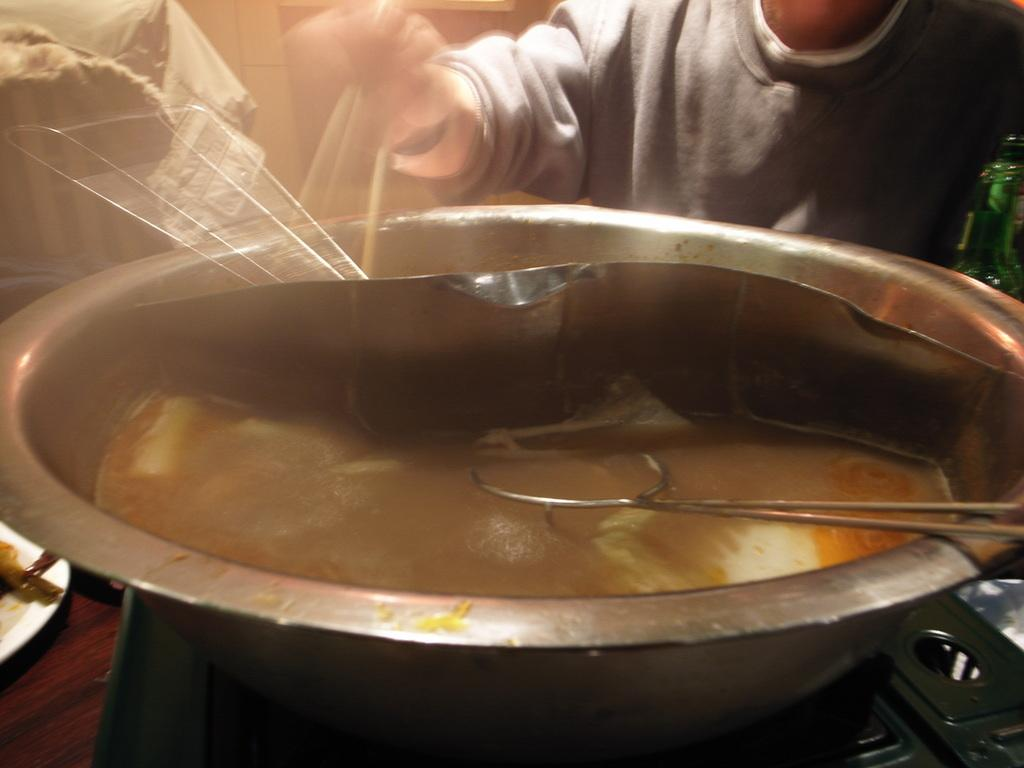What type of container is in the middle of the image? There is a steel container in the middle of the image. What is the position of the person in the image? The person is standing at the top of the image. Can you describe the container's material? The container is made of steel. How many grains of sand are visible on the person's shoes in the image? There is no sand or reference to sand in the image, so it is not possible to determine the number of grains on the person's shoes. 